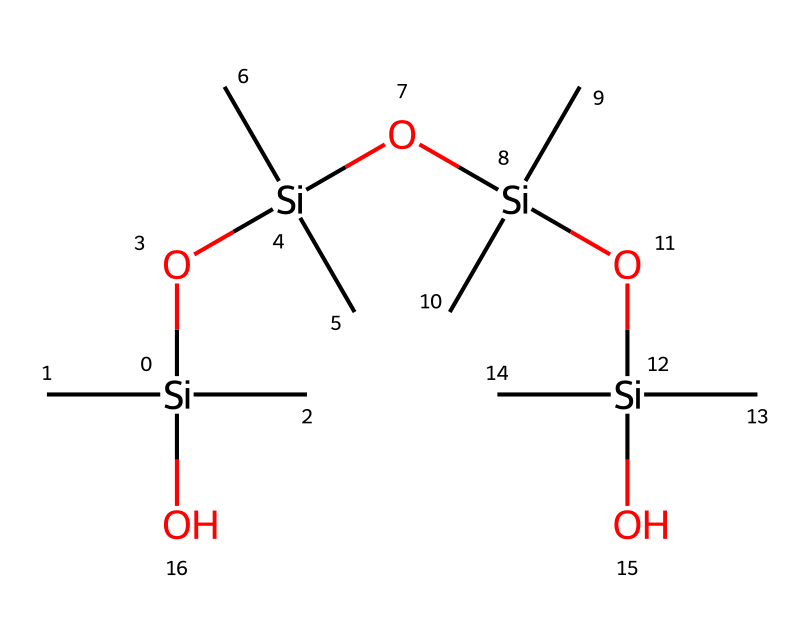What is the central atom in this chemical structure? The structure reveals silicon as the central atom because it is highlighted by the brackets surrounding it, indicating its coordination with other groups.
Answer: silicon How many oxygen atoms are present in the molecule? By inspecting the SMILES representation closely, there are four instances of 'O', indicating there are four oxygen atoms in total within the structure.
Answer: four What is the functional group present in this organosilicon compound? The presence of the 'O' atoms in the structure indicates that this compound contains silanol groups, defined by the 'Si-OH' linkage throughout the molecule.
Answer: silanol How many branched methyl groups (C) are found in the chemical? Each silicon atom is connected to three methyl groups surrounding it, and with three silicon atoms present, there are a total of nine methyl groups in the chemical structure.
Answer: nine What type of bond is primarily present between the silicon and oxygen atoms? The bond type between silicon and oxygen in organosilicon compounds is typically a covalent bond, as shown by their connection in the SMILES structure, which offers stability in the overall compound.
Answer: covalent How many silicon atoms are in this molecule? The SMILES representation indicates there are four silicon atoms, as identified by each occurrence of 'Si' in the structure.
Answer: four What property does the siloxane link provide to the sealant? The siloxane link enhances flexibility and durability due to its unique bond and structure, allowing the sealant to withstand environmental stressors without breaking.
Answer: flexibility 